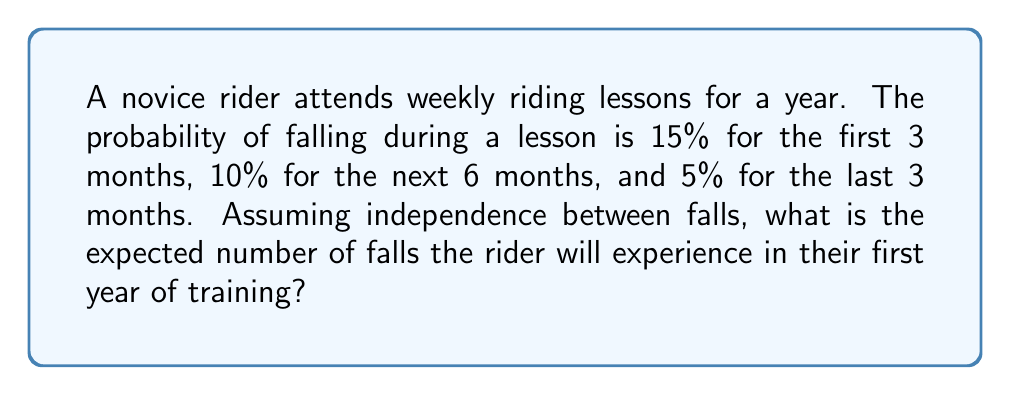Can you solve this math problem? Let's approach this step-by-step:

1) First, we need to calculate the number of lessons in each period:
   - First 3 months: $13 \text{ weeks} \times 1 \text{ lesson/week} = 13 \text{ lessons}$
   - Next 6 months: $26 \text{ weeks} \times 1 \text{ lesson/week} = 26 \text{ lessons}$
   - Last 3 months: $13 \text{ weeks} \times 1 \text{ lesson/week} = 13 \text{ lessons}$

2) Now, let's calculate the expected number of falls for each period:
   
   a) First 3 months:
      $E_1 = 13 \times 0.15 = 1.95 \text{ falls}$
   
   b) Next 6 months:
      $E_2 = 26 \times 0.10 = 2.60 \text{ falls}$
   
   c) Last 3 months:
      $E_3 = 13 \times 0.05 = 0.65 \text{ falls}$

3) The total expected number of falls is the sum of these expectations:

   $E_{\text{total}} = E_1 + E_2 + E_3 = 1.95 + 2.60 + 0.65 = 5.20 \text{ falls}$

Therefore, the expected number of falls in the first year of training is 5.20.
Answer: 5.20 falls 